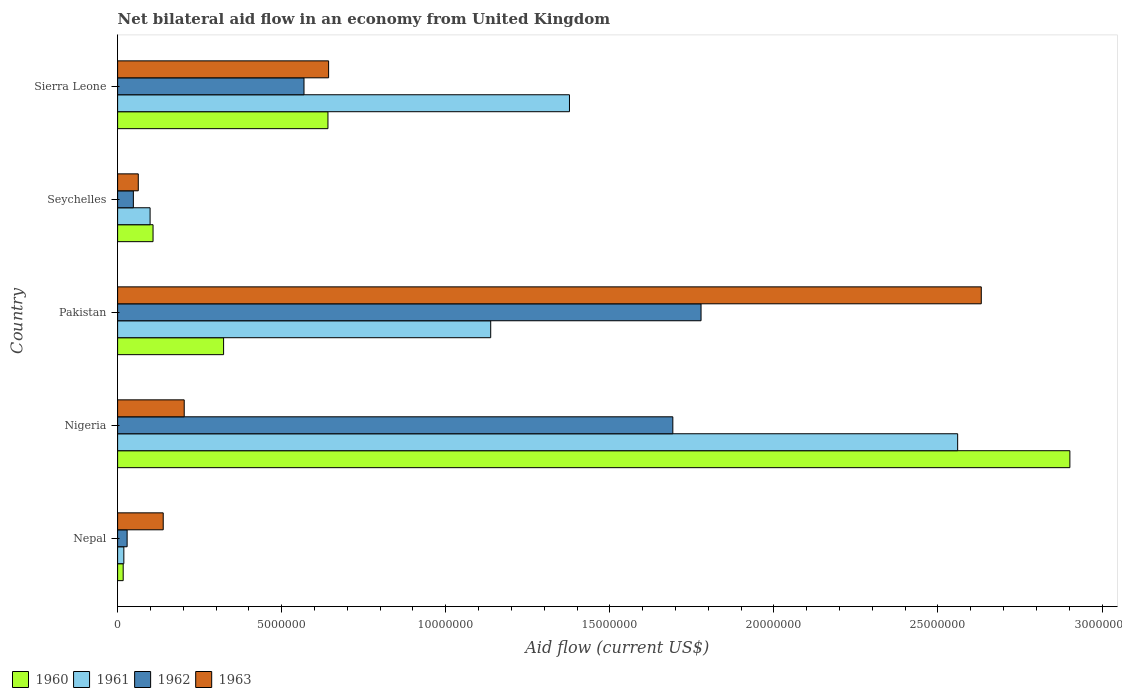How many different coloured bars are there?
Provide a short and direct response. 4. How many groups of bars are there?
Keep it short and to the point. 5. What is the label of the 1st group of bars from the top?
Offer a very short reply. Sierra Leone. In how many cases, is the number of bars for a given country not equal to the number of legend labels?
Your answer should be very brief. 0. What is the net bilateral aid flow in 1960 in Nepal?
Offer a very short reply. 1.70e+05. Across all countries, what is the maximum net bilateral aid flow in 1963?
Give a very brief answer. 2.63e+07. In which country was the net bilateral aid flow in 1962 maximum?
Provide a short and direct response. Pakistan. In which country was the net bilateral aid flow in 1962 minimum?
Provide a succinct answer. Nepal. What is the total net bilateral aid flow in 1963 in the graph?
Offer a terse response. 3.68e+07. What is the difference between the net bilateral aid flow in 1961 in Nepal and that in Seychelles?
Provide a succinct answer. -8.00e+05. What is the difference between the net bilateral aid flow in 1960 in Nigeria and the net bilateral aid flow in 1963 in Nepal?
Provide a succinct answer. 2.76e+07. What is the average net bilateral aid flow in 1960 per country?
Provide a succinct answer. 7.98e+06. What is the difference between the net bilateral aid flow in 1960 and net bilateral aid flow in 1963 in Nepal?
Make the answer very short. -1.22e+06. In how many countries, is the net bilateral aid flow in 1962 greater than 13000000 US$?
Your answer should be very brief. 2. What is the ratio of the net bilateral aid flow in 1962 in Nigeria to that in Seychelles?
Ensure brevity in your answer.  35.25. Is the difference between the net bilateral aid flow in 1960 in Nigeria and Sierra Leone greater than the difference between the net bilateral aid flow in 1963 in Nigeria and Sierra Leone?
Your response must be concise. Yes. What is the difference between the highest and the second highest net bilateral aid flow in 1960?
Provide a short and direct response. 2.26e+07. What is the difference between the highest and the lowest net bilateral aid flow in 1961?
Your answer should be very brief. 2.54e+07. In how many countries, is the net bilateral aid flow in 1960 greater than the average net bilateral aid flow in 1960 taken over all countries?
Ensure brevity in your answer.  1. Is it the case that in every country, the sum of the net bilateral aid flow in 1960 and net bilateral aid flow in 1963 is greater than the sum of net bilateral aid flow in 1961 and net bilateral aid flow in 1962?
Your response must be concise. No. What does the 4th bar from the top in Seychelles represents?
Make the answer very short. 1960. What does the 1st bar from the bottom in Seychelles represents?
Your answer should be very brief. 1960. Is it the case that in every country, the sum of the net bilateral aid flow in 1960 and net bilateral aid flow in 1962 is greater than the net bilateral aid flow in 1961?
Provide a short and direct response. No. What is the difference between two consecutive major ticks on the X-axis?
Ensure brevity in your answer.  5.00e+06. Are the values on the major ticks of X-axis written in scientific E-notation?
Keep it short and to the point. No. Does the graph contain any zero values?
Provide a succinct answer. No. Does the graph contain grids?
Make the answer very short. No. Where does the legend appear in the graph?
Your response must be concise. Bottom left. How many legend labels are there?
Your answer should be compact. 4. What is the title of the graph?
Provide a short and direct response. Net bilateral aid flow in an economy from United Kingdom. Does "1973" appear as one of the legend labels in the graph?
Your answer should be very brief. No. What is the label or title of the X-axis?
Make the answer very short. Aid flow (current US$). What is the Aid flow (current US$) in 1963 in Nepal?
Your answer should be compact. 1.39e+06. What is the Aid flow (current US$) in 1960 in Nigeria?
Your answer should be very brief. 2.90e+07. What is the Aid flow (current US$) of 1961 in Nigeria?
Your answer should be very brief. 2.56e+07. What is the Aid flow (current US$) of 1962 in Nigeria?
Ensure brevity in your answer.  1.69e+07. What is the Aid flow (current US$) in 1963 in Nigeria?
Your answer should be very brief. 2.03e+06. What is the Aid flow (current US$) of 1960 in Pakistan?
Your answer should be compact. 3.23e+06. What is the Aid flow (current US$) of 1961 in Pakistan?
Ensure brevity in your answer.  1.14e+07. What is the Aid flow (current US$) of 1962 in Pakistan?
Your answer should be very brief. 1.78e+07. What is the Aid flow (current US$) of 1963 in Pakistan?
Your response must be concise. 2.63e+07. What is the Aid flow (current US$) in 1960 in Seychelles?
Provide a succinct answer. 1.08e+06. What is the Aid flow (current US$) of 1961 in Seychelles?
Ensure brevity in your answer.  9.90e+05. What is the Aid flow (current US$) in 1962 in Seychelles?
Make the answer very short. 4.80e+05. What is the Aid flow (current US$) in 1963 in Seychelles?
Offer a terse response. 6.30e+05. What is the Aid flow (current US$) of 1960 in Sierra Leone?
Offer a very short reply. 6.41e+06. What is the Aid flow (current US$) in 1961 in Sierra Leone?
Make the answer very short. 1.38e+07. What is the Aid flow (current US$) of 1962 in Sierra Leone?
Your response must be concise. 5.68e+06. What is the Aid flow (current US$) in 1963 in Sierra Leone?
Make the answer very short. 6.43e+06. Across all countries, what is the maximum Aid flow (current US$) of 1960?
Your answer should be very brief. 2.90e+07. Across all countries, what is the maximum Aid flow (current US$) of 1961?
Your answer should be very brief. 2.56e+07. Across all countries, what is the maximum Aid flow (current US$) in 1962?
Provide a short and direct response. 1.78e+07. Across all countries, what is the maximum Aid flow (current US$) of 1963?
Your answer should be very brief. 2.63e+07. Across all countries, what is the minimum Aid flow (current US$) of 1960?
Keep it short and to the point. 1.70e+05. Across all countries, what is the minimum Aid flow (current US$) of 1962?
Provide a succinct answer. 2.90e+05. Across all countries, what is the minimum Aid flow (current US$) of 1963?
Make the answer very short. 6.30e+05. What is the total Aid flow (current US$) in 1960 in the graph?
Your answer should be compact. 3.99e+07. What is the total Aid flow (current US$) of 1961 in the graph?
Offer a very short reply. 5.19e+07. What is the total Aid flow (current US$) of 1962 in the graph?
Provide a succinct answer. 4.12e+07. What is the total Aid flow (current US$) in 1963 in the graph?
Offer a terse response. 3.68e+07. What is the difference between the Aid flow (current US$) in 1960 in Nepal and that in Nigeria?
Provide a succinct answer. -2.88e+07. What is the difference between the Aid flow (current US$) of 1961 in Nepal and that in Nigeria?
Provide a succinct answer. -2.54e+07. What is the difference between the Aid flow (current US$) in 1962 in Nepal and that in Nigeria?
Provide a succinct answer. -1.66e+07. What is the difference between the Aid flow (current US$) of 1963 in Nepal and that in Nigeria?
Offer a very short reply. -6.40e+05. What is the difference between the Aid flow (current US$) in 1960 in Nepal and that in Pakistan?
Your answer should be compact. -3.06e+06. What is the difference between the Aid flow (current US$) in 1961 in Nepal and that in Pakistan?
Your response must be concise. -1.12e+07. What is the difference between the Aid flow (current US$) in 1962 in Nepal and that in Pakistan?
Your answer should be compact. -1.75e+07. What is the difference between the Aid flow (current US$) of 1963 in Nepal and that in Pakistan?
Ensure brevity in your answer.  -2.49e+07. What is the difference between the Aid flow (current US$) of 1960 in Nepal and that in Seychelles?
Provide a succinct answer. -9.10e+05. What is the difference between the Aid flow (current US$) in 1961 in Nepal and that in Seychelles?
Ensure brevity in your answer.  -8.00e+05. What is the difference between the Aid flow (current US$) in 1963 in Nepal and that in Seychelles?
Ensure brevity in your answer.  7.60e+05. What is the difference between the Aid flow (current US$) in 1960 in Nepal and that in Sierra Leone?
Offer a terse response. -6.24e+06. What is the difference between the Aid flow (current US$) in 1961 in Nepal and that in Sierra Leone?
Ensure brevity in your answer.  -1.36e+07. What is the difference between the Aid flow (current US$) of 1962 in Nepal and that in Sierra Leone?
Ensure brevity in your answer.  -5.39e+06. What is the difference between the Aid flow (current US$) of 1963 in Nepal and that in Sierra Leone?
Keep it short and to the point. -5.04e+06. What is the difference between the Aid flow (current US$) in 1960 in Nigeria and that in Pakistan?
Give a very brief answer. 2.58e+07. What is the difference between the Aid flow (current US$) in 1961 in Nigeria and that in Pakistan?
Provide a succinct answer. 1.42e+07. What is the difference between the Aid flow (current US$) in 1962 in Nigeria and that in Pakistan?
Offer a terse response. -8.60e+05. What is the difference between the Aid flow (current US$) in 1963 in Nigeria and that in Pakistan?
Provide a succinct answer. -2.43e+07. What is the difference between the Aid flow (current US$) in 1960 in Nigeria and that in Seychelles?
Make the answer very short. 2.79e+07. What is the difference between the Aid flow (current US$) of 1961 in Nigeria and that in Seychelles?
Provide a short and direct response. 2.46e+07. What is the difference between the Aid flow (current US$) in 1962 in Nigeria and that in Seychelles?
Your answer should be compact. 1.64e+07. What is the difference between the Aid flow (current US$) in 1963 in Nigeria and that in Seychelles?
Make the answer very short. 1.40e+06. What is the difference between the Aid flow (current US$) in 1960 in Nigeria and that in Sierra Leone?
Give a very brief answer. 2.26e+07. What is the difference between the Aid flow (current US$) of 1961 in Nigeria and that in Sierra Leone?
Your response must be concise. 1.18e+07. What is the difference between the Aid flow (current US$) of 1962 in Nigeria and that in Sierra Leone?
Provide a short and direct response. 1.12e+07. What is the difference between the Aid flow (current US$) of 1963 in Nigeria and that in Sierra Leone?
Give a very brief answer. -4.40e+06. What is the difference between the Aid flow (current US$) of 1960 in Pakistan and that in Seychelles?
Offer a terse response. 2.15e+06. What is the difference between the Aid flow (current US$) in 1961 in Pakistan and that in Seychelles?
Offer a terse response. 1.04e+07. What is the difference between the Aid flow (current US$) of 1962 in Pakistan and that in Seychelles?
Your answer should be very brief. 1.73e+07. What is the difference between the Aid flow (current US$) in 1963 in Pakistan and that in Seychelles?
Your answer should be very brief. 2.57e+07. What is the difference between the Aid flow (current US$) of 1960 in Pakistan and that in Sierra Leone?
Your answer should be compact. -3.18e+06. What is the difference between the Aid flow (current US$) of 1961 in Pakistan and that in Sierra Leone?
Keep it short and to the point. -2.40e+06. What is the difference between the Aid flow (current US$) of 1962 in Pakistan and that in Sierra Leone?
Provide a succinct answer. 1.21e+07. What is the difference between the Aid flow (current US$) of 1963 in Pakistan and that in Sierra Leone?
Provide a succinct answer. 1.99e+07. What is the difference between the Aid flow (current US$) in 1960 in Seychelles and that in Sierra Leone?
Offer a very short reply. -5.33e+06. What is the difference between the Aid flow (current US$) of 1961 in Seychelles and that in Sierra Leone?
Offer a terse response. -1.28e+07. What is the difference between the Aid flow (current US$) of 1962 in Seychelles and that in Sierra Leone?
Give a very brief answer. -5.20e+06. What is the difference between the Aid flow (current US$) in 1963 in Seychelles and that in Sierra Leone?
Offer a very short reply. -5.80e+06. What is the difference between the Aid flow (current US$) of 1960 in Nepal and the Aid flow (current US$) of 1961 in Nigeria?
Make the answer very short. -2.54e+07. What is the difference between the Aid flow (current US$) of 1960 in Nepal and the Aid flow (current US$) of 1962 in Nigeria?
Provide a succinct answer. -1.68e+07. What is the difference between the Aid flow (current US$) in 1960 in Nepal and the Aid flow (current US$) in 1963 in Nigeria?
Your response must be concise. -1.86e+06. What is the difference between the Aid flow (current US$) of 1961 in Nepal and the Aid flow (current US$) of 1962 in Nigeria?
Offer a very short reply. -1.67e+07. What is the difference between the Aid flow (current US$) in 1961 in Nepal and the Aid flow (current US$) in 1963 in Nigeria?
Give a very brief answer. -1.84e+06. What is the difference between the Aid flow (current US$) in 1962 in Nepal and the Aid flow (current US$) in 1963 in Nigeria?
Your answer should be compact. -1.74e+06. What is the difference between the Aid flow (current US$) of 1960 in Nepal and the Aid flow (current US$) of 1961 in Pakistan?
Make the answer very short. -1.12e+07. What is the difference between the Aid flow (current US$) of 1960 in Nepal and the Aid flow (current US$) of 1962 in Pakistan?
Keep it short and to the point. -1.76e+07. What is the difference between the Aid flow (current US$) in 1960 in Nepal and the Aid flow (current US$) in 1963 in Pakistan?
Offer a very short reply. -2.62e+07. What is the difference between the Aid flow (current US$) of 1961 in Nepal and the Aid flow (current US$) of 1962 in Pakistan?
Make the answer very short. -1.76e+07. What is the difference between the Aid flow (current US$) of 1961 in Nepal and the Aid flow (current US$) of 1963 in Pakistan?
Your response must be concise. -2.61e+07. What is the difference between the Aid flow (current US$) in 1962 in Nepal and the Aid flow (current US$) in 1963 in Pakistan?
Provide a short and direct response. -2.60e+07. What is the difference between the Aid flow (current US$) in 1960 in Nepal and the Aid flow (current US$) in 1961 in Seychelles?
Give a very brief answer. -8.20e+05. What is the difference between the Aid flow (current US$) in 1960 in Nepal and the Aid flow (current US$) in 1962 in Seychelles?
Offer a very short reply. -3.10e+05. What is the difference between the Aid flow (current US$) in 1960 in Nepal and the Aid flow (current US$) in 1963 in Seychelles?
Offer a very short reply. -4.60e+05. What is the difference between the Aid flow (current US$) in 1961 in Nepal and the Aid flow (current US$) in 1962 in Seychelles?
Keep it short and to the point. -2.90e+05. What is the difference between the Aid flow (current US$) in 1961 in Nepal and the Aid flow (current US$) in 1963 in Seychelles?
Provide a succinct answer. -4.40e+05. What is the difference between the Aid flow (current US$) of 1962 in Nepal and the Aid flow (current US$) of 1963 in Seychelles?
Give a very brief answer. -3.40e+05. What is the difference between the Aid flow (current US$) in 1960 in Nepal and the Aid flow (current US$) in 1961 in Sierra Leone?
Your answer should be very brief. -1.36e+07. What is the difference between the Aid flow (current US$) of 1960 in Nepal and the Aid flow (current US$) of 1962 in Sierra Leone?
Provide a succinct answer. -5.51e+06. What is the difference between the Aid flow (current US$) in 1960 in Nepal and the Aid flow (current US$) in 1963 in Sierra Leone?
Your answer should be compact. -6.26e+06. What is the difference between the Aid flow (current US$) of 1961 in Nepal and the Aid flow (current US$) of 1962 in Sierra Leone?
Your response must be concise. -5.49e+06. What is the difference between the Aid flow (current US$) of 1961 in Nepal and the Aid flow (current US$) of 1963 in Sierra Leone?
Keep it short and to the point. -6.24e+06. What is the difference between the Aid flow (current US$) of 1962 in Nepal and the Aid flow (current US$) of 1963 in Sierra Leone?
Provide a short and direct response. -6.14e+06. What is the difference between the Aid flow (current US$) of 1960 in Nigeria and the Aid flow (current US$) of 1961 in Pakistan?
Your response must be concise. 1.76e+07. What is the difference between the Aid flow (current US$) of 1960 in Nigeria and the Aid flow (current US$) of 1962 in Pakistan?
Ensure brevity in your answer.  1.12e+07. What is the difference between the Aid flow (current US$) of 1960 in Nigeria and the Aid flow (current US$) of 1963 in Pakistan?
Your answer should be very brief. 2.70e+06. What is the difference between the Aid flow (current US$) in 1961 in Nigeria and the Aid flow (current US$) in 1962 in Pakistan?
Your answer should be compact. 7.82e+06. What is the difference between the Aid flow (current US$) of 1961 in Nigeria and the Aid flow (current US$) of 1963 in Pakistan?
Your answer should be compact. -7.20e+05. What is the difference between the Aid flow (current US$) in 1962 in Nigeria and the Aid flow (current US$) in 1963 in Pakistan?
Offer a terse response. -9.40e+06. What is the difference between the Aid flow (current US$) of 1960 in Nigeria and the Aid flow (current US$) of 1961 in Seychelles?
Your response must be concise. 2.80e+07. What is the difference between the Aid flow (current US$) of 1960 in Nigeria and the Aid flow (current US$) of 1962 in Seychelles?
Ensure brevity in your answer.  2.85e+07. What is the difference between the Aid flow (current US$) in 1960 in Nigeria and the Aid flow (current US$) in 1963 in Seychelles?
Ensure brevity in your answer.  2.84e+07. What is the difference between the Aid flow (current US$) of 1961 in Nigeria and the Aid flow (current US$) of 1962 in Seychelles?
Keep it short and to the point. 2.51e+07. What is the difference between the Aid flow (current US$) in 1961 in Nigeria and the Aid flow (current US$) in 1963 in Seychelles?
Ensure brevity in your answer.  2.50e+07. What is the difference between the Aid flow (current US$) of 1962 in Nigeria and the Aid flow (current US$) of 1963 in Seychelles?
Make the answer very short. 1.63e+07. What is the difference between the Aid flow (current US$) in 1960 in Nigeria and the Aid flow (current US$) in 1961 in Sierra Leone?
Your answer should be compact. 1.52e+07. What is the difference between the Aid flow (current US$) in 1960 in Nigeria and the Aid flow (current US$) in 1962 in Sierra Leone?
Make the answer very short. 2.33e+07. What is the difference between the Aid flow (current US$) of 1960 in Nigeria and the Aid flow (current US$) of 1963 in Sierra Leone?
Keep it short and to the point. 2.26e+07. What is the difference between the Aid flow (current US$) in 1961 in Nigeria and the Aid flow (current US$) in 1962 in Sierra Leone?
Keep it short and to the point. 1.99e+07. What is the difference between the Aid flow (current US$) in 1961 in Nigeria and the Aid flow (current US$) in 1963 in Sierra Leone?
Provide a succinct answer. 1.92e+07. What is the difference between the Aid flow (current US$) in 1962 in Nigeria and the Aid flow (current US$) in 1963 in Sierra Leone?
Offer a very short reply. 1.05e+07. What is the difference between the Aid flow (current US$) in 1960 in Pakistan and the Aid flow (current US$) in 1961 in Seychelles?
Provide a succinct answer. 2.24e+06. What is the difference between the Aid flow (current US$) in 1960 in Pakistan and the Aid flow (current US$) in 1962 in Seychelles?
Your answer should be compact. 2.75e+06. What is the difference between the Aid flow (current US$) in 1960 in Pakistan and the Aid flow (current US$) in 1963 in Seychelles?
Your answer should be compact. 2.60e+06. What is the difference between the Aid flow (current US$) in 1961 in Pakistan and the Aid flow (current US$) in 1962 in Seychelles?
Ensure brevity in your answer.  1.09e+07. What is the difference between the Aid flow (current US$) of 1961 in Pakistan and the Aid flow (current US$) of 1963 in Seychelles?
Your response must be concise. 1.07e+07. What is the difference between the Aid flow (current US$) of 1962 in Pakistan and the Aid flow (current US$) of 1963 in Seychelles?
Your answer should be compact. 1.72e+07. What is the difference between the Aid flow (current US$) in 1960 in Pakistan and the Aid flow (current US$) in 1961 in Sierra Leone?
Offer a very short reply. -1.05e+07. What is the difference between the Aid flow (current US$) in 1960 in Pakistan and the Aid flow (current US$) in 1962 in Sierra Leone?
Ensure brevity in your answer.  -2.45e+06. What is the difference between the Aid flow (current US$) of 1960 in Pakistan and the Aid flow (current US$) of 1963 in Sierra Leone?
Your answer should be very brief. -3.20e+06. What is the difference between the Aid flow (current US$) of 1961 in Pakistan and the Aid flow (current US$) of 1962 in Sierra Leone?
Offer a very short reply. 5.69e+06. What is the difference between the Aid flow (current US$) in 1961 in Pakistan and the Aid flow (current US$) in 1963 in Sierra Leone?
Ensure brevity in your answer.  4.94e+06. What is the difference between the Aid flow (current US$) of 1962 in Pakistan and the Aid flow (current US$) of 1963 in Sierra Leone?
Make the answer very short. 1.14e+07. What is the difference between the Aid flow (current US$) in 1960 in Seychelles and the Aid flow (current US$) in 1961 in Sierra Leone?
Give a very brief answer. -1.27e+07. What is the difference between the Aid flow (current US$) in 1960 in Seychelles and the Aid flow (current US$) in 1962 in Sierra Leone?
Provide a succinct answer. -4.60e+06. What is the difference between the Aid flow (current US$) of 1960 in Seychelles and the Aid flow (current US$) of 1963 in Sierra Leone?
Offer a terse response. -5.35e+06. What is the difference between the Aid flow (current US$) in 1961 in Seychelles and the Aid flow (current US$) in 1962 in Sierra Leone?
Give a very brief answer. -4.69e+06. What is the difference between the Aid flow (current US$) in 1961 in Seychelles and the Aid flow (current US$) in 1963 in Sierra Leone?
Provide a short and direct response. -5.44e+06. What is the difference between the Aid flow (current US$) of 1962 in Seychelles and the Aid flow (current US$) of 1963 in Sierra Leone?
Make the answer very short. -5.95e+06. What is the average Aid flow (current US$) in 1960 per country?
Give a very brief answer. 7.98e+06. What is the average Aid flow (current US$) in 1961 per country?
Your response must be concise. 1.04e+07. What is the average Aid flow (current US$) of 1962 per country?
Your answer should be compact. 8.23e+06. What is the average Aid flow (current US$) of 1963 per country?
Keep it short and to the point. 7.36e+06. What is the difference between the Aid flow (current US$) in 1960 and Aid flow (current US$) in 1961 in Nepal?
Your answer should be very brief. -2.00e+04. What is the difference between the Aid flow (current US$) of 1960 and Aid flow (current US$) of 1963 in Nepal?
Offer a terse response. -1.22e+06. What is the difference between the Aid flow (current US$) in 1961 and Aid flow (current US$) in 1962 in Nepal?
Provide a succinct answer. -1.00e+05. What is the difference between the Aid flow (current US$) of 1961 and Aid flow (current US$) of 1963 in Nepal?
Give a very brief answer. -1.20e+06. What is the difference between the Aid flow (current US$) of 1962 and Aid flow (current US$) of 1963 in Nepal?
Give a very brief answer. -1.10e+06. What is the difference between the Aid flow (current US$) of 1960 and Aid flow (current US$) of 1961 in Nigeria?
Your answer should be compact. 3.42e+06. What is the difference between the Aid flow (current US$) of 1960 and Aid flow (current US$) of 1962 in Nigeria?
Offer a terse response. 1.21e+07. What is the difference between the Aid flow (current US$) in 1960 and Aid flow (current US$) in 1963 in Nigeria?
Offer a very short reply. 2.70e+07. What is the difference between the Aid flow (current US$) in 1961 and Aid flow (current US$) in 1962 in Nigeria?
Ensure brevity in your answer.  8.68e+06. What is the difference between the Aid flow (current US$) in 1961 and Aid flow (current US$) in 1963 in Nigeria?
Your response must be concise. 2.36e+07. What is the difference between the Aid flow (current US$) in 1962 and Aid flow (current US$) in 1963 in Nigeria?
Provide a succinct answer. 1.49e+07. What is the difference between the Aid flow (current US$) of 1960 and Aid flow (current US$) of 1961 in Pakistan?
Your answer should be very brief. -8.14e+06. What is the difference between the Aid flow (current US$) of 1960 and Aid flow (current US$) of 1962 in Pakistan?
Provide a short and direct response. -1.46e+07. What is the difference between the Aid flow (current US$) in 1960 and Aid flow (current US$) in 1963 in Pakistan?
Keep it short and to the point. -2.31e+07. What is the difference between the Aid flow (current US$) in 1961 and Aid flow (current US$) in 1962 in Pakistan?
Your response must be concise. -6.41e+06. What is the difference between the Aid flow (current US$) of 1961 and Aid flow (current US$) of 1963 in Pakistan?
Give a very brief answer. -1.50e+07. What is the difference between the Aid flow (current US$) of 1962 and Aid flow (current US$) of 1963 in Pakistan?
Provide a short and direct response. -8.54e+06. What is the difference between the Aid flow (current US$) of 1961 and Aid flow (current US$) of 1962 in Seychelles?
Your response must be concise. 5.10e+05. What is the difference between the Aid flow (current US$) of 1961 and Aid flow (current US$) of 1963 in Seychelles?
Keep it short and to the point. 3.60e+05. What is the difference between the Aid flow (current US$) in 1962 and Aid flow (current US$) in 1963 in Seychelles?
Ensure brevity in your answer.  -1.50e+05. What is the difference between the Aid flow (current US$) in 1960 and Aid flow (current US$) in 1961 in Sierra Leone?
Provide a short and direct response. -7.36e+06. What is the difference between the Aid flow (current US$) in 1960 and Aid flow (current US$) in 1962 in Sierra Leone?
Offer a very short reply. 7.30e+05. What is the difference between the Aid flow (current US$) of 1961 and Aid flow (current US$) of 1962 in Sierra Leone?
Keep it short and to the point. 8.09e+06. What is the difference between the Aid flow (current US$) of 1961 and Aid flow (current US$) of 1963 in Sierra Leone?
Make the answer very short. 7.34e+06. What is the difference between the Aid flow (current US$) of 1962 and Aid flow (current US$) of 1963 in Sierra Leone?
Your answer should be compact. -7.50e+05. What is the ratio of the Aid flow (current US$) of 1960 in Nepal to that in Nigeria?
Your answer should be very brief. 0.01. What is the ratio of the Aid flow (current US$) of 1961 in Nepal to that in Nigeria?
Provide a succinct answer. 0.01. What is the ratio of the Aid flow (current US$) in 1962 in Nepal to that in Nigeria?
Provide a succinct answer. 0.02. What is the ratio of the Aid flow (current US$) of 1963 in Nepal to that in Nigeria?
Make the answer very short. 0.68. What is the ratio of the Aid flow (current US$) in 1960 in Nepal to that in Pakistan?
Make the answer very short. 0.05. What is the ratio of the Aid flow (current US$) of 1961 in Nepal to that in Pakistan?
Provide a succinct answer. 0.02. What is the ratio of the Aid flow (current US$) in 1962 in Nepal to that in Pakistan?
Ensure brevity in your answer.  0.02. What is the ratio of the Aid flow (current US$) in 1963 in Nepal to that in Pakistan?
Give a very brief answer. 0.05. What is the ratio of the Aid flow (current US$) of 1960 in Nepal to that in Seychelles?
Keep it short and to the point. 0.16. What is the ratio of the Aid flow (current US$) of 1961 in Nepal to that in Seychelles?
Your answer should be very brief. 0.19. What is the ratio of the Aid flow (current US$) of 1962 in Nepal to that in Seychelles?
Your response must be concise. 0.6. What is the ratio of the Aid flow (current US$) in 1963 in Nepal to that in Seychelles?
Make the answer very short. 2.21. What is the ratio of the Aid flow (current US$) in 1960 in Nepal to that in Sierra Leone?
Your answer should be very brief. 0.03. What is the ratio of the Aid flow (current US$) of 1961 in Nepal to that in Sierra Leone?
Give a very brief answer. 0.01. What is the ratio of the Aid flow (current US$) in 1962 in Nepal to that in Sierra Leone?
Keep it short and to the point. 0.05. What is the ratio of the Aid flow (current US$) of 1963 in Nepal to that in Sierra Leone?
Offer a very short reply. 0.22. What is the ratio of the Aid flow (current US$) of 1960 in Nigeria to that in Pakistan?
Your response must be concise. 8.98. What is the ratio of the Aid flow (current US$) in 1961 in Nigeria to that in Pakistan?
Your answer should be very brief. 2.25. What is the ratio of the Aid flow (current US$) of 1962 in Nigeria to that in Pakistan?
Your response must be concise. 0.95. What is the ratio of the Aid flow (current US$) in 1963 in Nigeria to that in Pakistan?
Keep it short and to the point. 0.08. What is the ratio of the Aid flow (current US$) in 1960 in Nigeria to that in Seychelles?
Your response must be concise. 26.87. What is the ratio of the Aid flow (current US$) in 1961 in Nigeria to that in Seychelles?
Ensure brevity in your answer.  25.86. What is the ratio of the Aid flow (current US$) in 1962 in Nigeria to that in Seychelles?
Ensure brevity in your answer.  35.25. What is the ratio of the Aid flow (current US$) of 1963 in Nigeria to that in Seychelles?
Give a very brief answer. 3.22. What is the ratio of the Aid flow (current US$) in 1960 in Nigeria to that in Sierra Leone?
Keep it short and to the point. 4.53. What is the ratio of the Aid flow (current US$) of 1961 in Nigeria to that in Sierra Leone?
Give a very brief answer. 1.86. What is the ratio of the Aid flow (current US$) of 1962 in Nigeria to that in Sierra Leone?
Provide a succinct answer. 2.98. What is the ratio of the Aid flow (current US$) in 1963 in Nigeria to that in Sierra Leone?
Give a very brief answer. 0.32. What is the ratio of the Aid flow (current US$) of 1960 in Pakistan to that in Seychelles?
Provide a short and direct response. 2.99. What is the ratio of the Aid flow (current US$) in 1961 in Pakistan to that in Seychelles?
Your answer should be very brief. 11.48. What is the ratio of the Aid flow (current US$) of 1962 in Pakistan to that in Seychelles?
Offer a terse response. 37.04. What is the ratio of the Aid flow (current US$) of 1963 in Pakistan to that in Seychelles?
Provide a succinct answer. 41.78. What is the ratio of the Aid flow (current US$) in 1960 in Pakistan to that in Sierra Leone?
Keep it short and to the point. 0.5. What is the ratio of the Aid flow (current US$) of 1961 in Pakistan to that in Sierra Leone?
Offer a very short reply. 0.83. What is the ratio of the Aid flow (current US$) in 1962 in Pakistan to that in Sierra Leone?
Offer a very short reply. 3.13. What is the ratio of the Aid flow (current US$) in 1963 in Pakistan to that in Sierra Leone?
Keep it short and to the point. 4.09. What is the ratio of the Aid flow (current US$) of 1960 in Seychelles to that in Sierra Leone?
Your response must be concise. 0.17. What is the ratio of the Aid flow (current US$) of 1961 in Seychelles to that in Sierra Leone?
Provide a short and direct response. 0.07. What is the ratio of the Aid flow (current US$) in 1962 in Seychelles to that in Sierra Leone?
Give a very brief answer. 0.08. What is the ratio of the Aid flow (current US$) of 1963 in Seychelles to that in Sierra Leone?
Offer a very short reply. 0.1. What is the difference between the highest and the second highest Aid flow (current US$) in 1960?
Make the answer very short. 2.26e+07. What is the difference between the highest and the second highest Aid flow (current US$) in 1961?
Offer a terse response. 1.18e+07. What is the difference between the highest and the second highest Aid flow (current US$) in 1962?
Give a very brief answer. 8.60e+05. What is the difference between the highest and the second highest Aid flow (current US$) of 1963?
Offer a terse response. 1.99e+07. What is the difference between the highest and the lowest Aid flow (current US$) of 1960?
Offer a terse response. 2.88e+07. What is the difference between the highest and the lowest Aid flow (current US$) in 1961?
Your answer should be compact. 2.54e+07. What is the difference between the highest and the lowest Aid flow (current US$) in 1962?
Your answer should be very brief. 1.75e+07. What is the difference between the highest and the lowest Aid flow (current US$) of 1963?
Your response must be concise. 2.57e+07. 